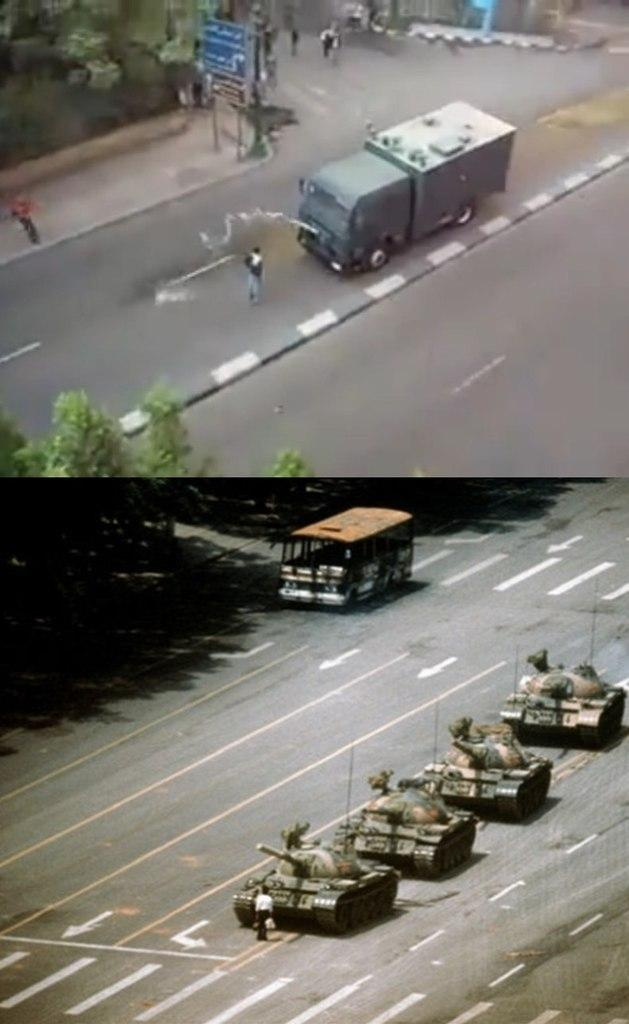What is the main subject of the image? The main subject of the image is a group of people. What else can be seen in the image besides the group of people? There are vehicles on the road and trees visible in the image. Are there any signs or notices in the image? Yes, there are sign boards in the image. What type of cake is being served on the chessboard in the image? There is no cake or chessboard present in the image. 